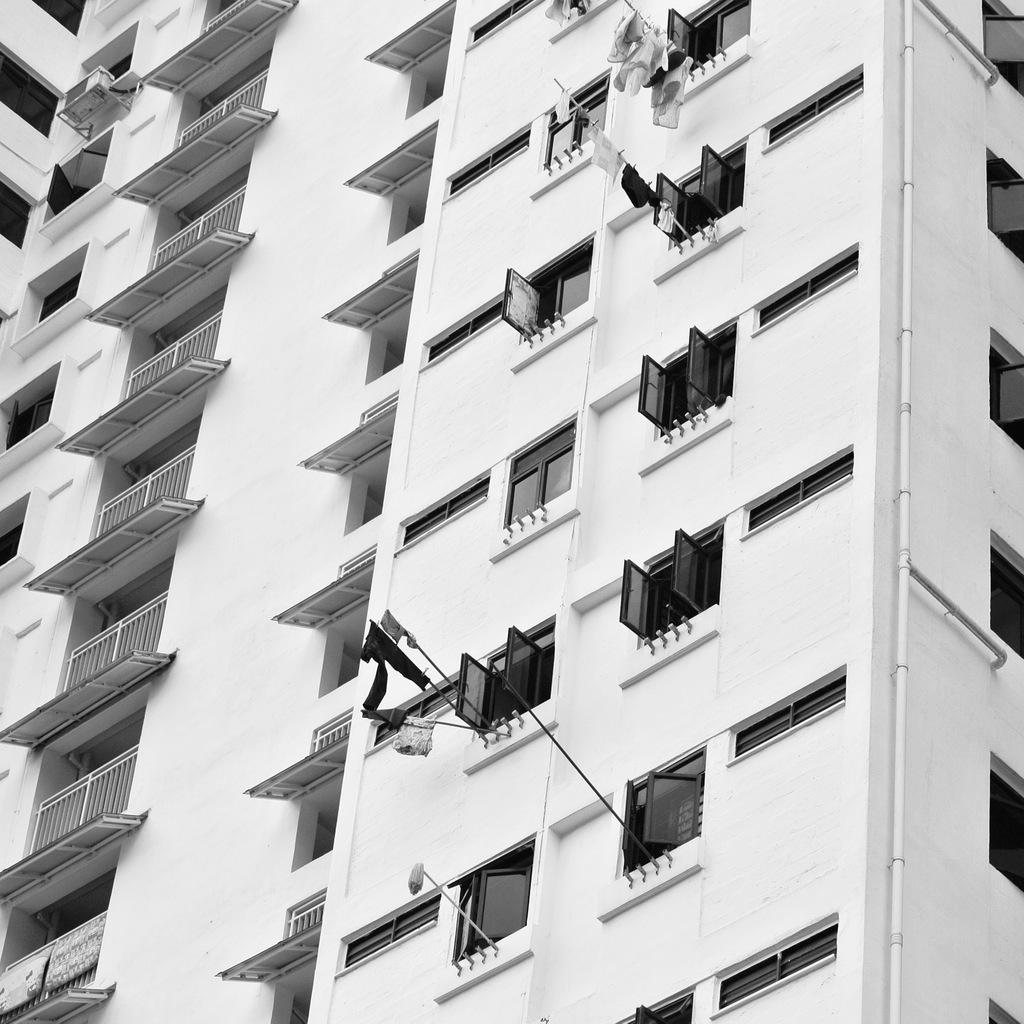What type of structure is visible in the image? There is a building in the image. What feature can be seen on the building? There are glass windows on the building. Are all the windows closed or are some open? Some of the glass windows are opened. What is attached to a pole in the image? There are clothes attached to a pole in the image. What type of silk is being used to make the badge in the image? There is no badge or silk present in the image. 